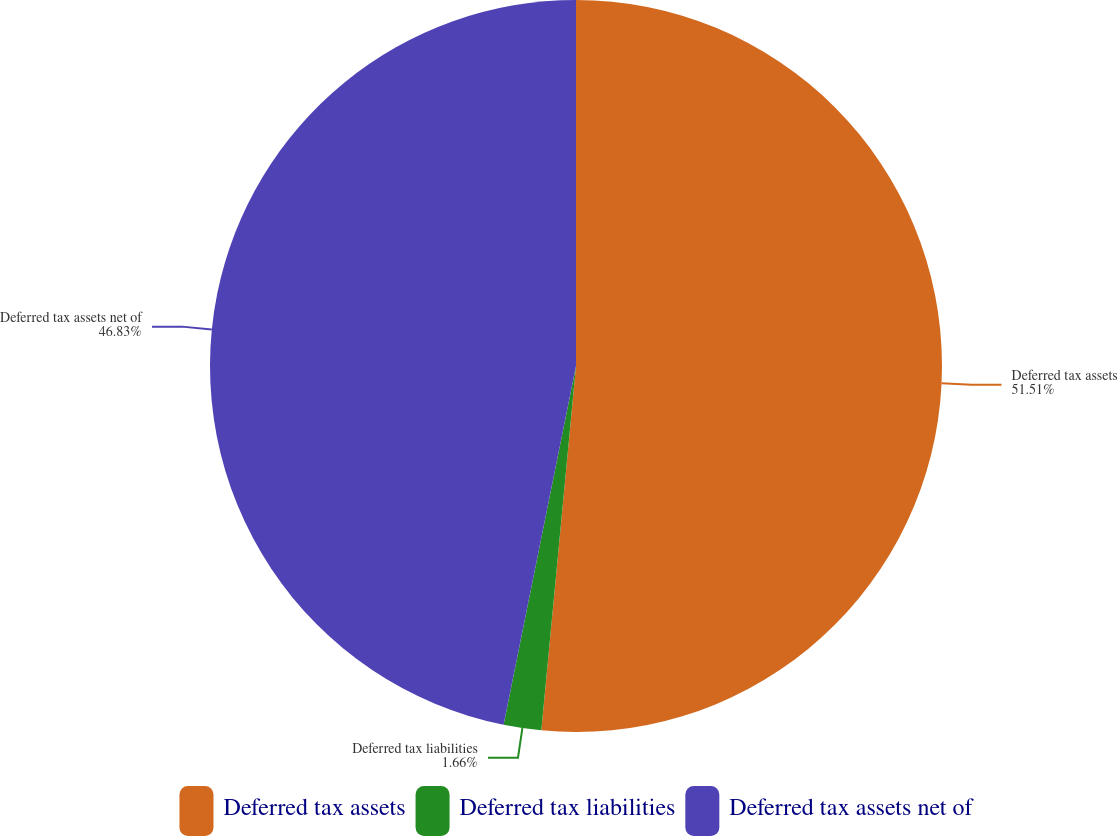<chart> <loc_0><loc_0><loc_500><loc_500><pie_chart><fcel>Deferred tax assets<fcel>Deferred tax liabilities<fcel>Deferred tax assets net of<nl><fcel>51.51%<fcel>1.66%<fcel>46.83%<nl></chart> 